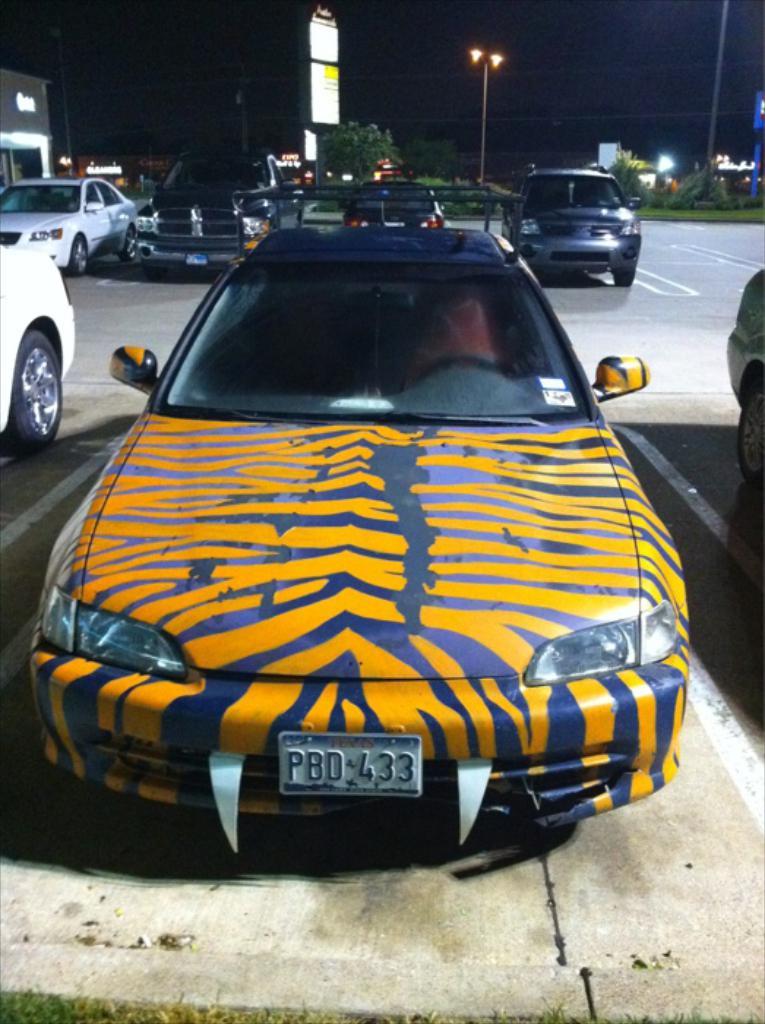What is the plate number?
Ensure brevity in your answer.  Pbd 433. 